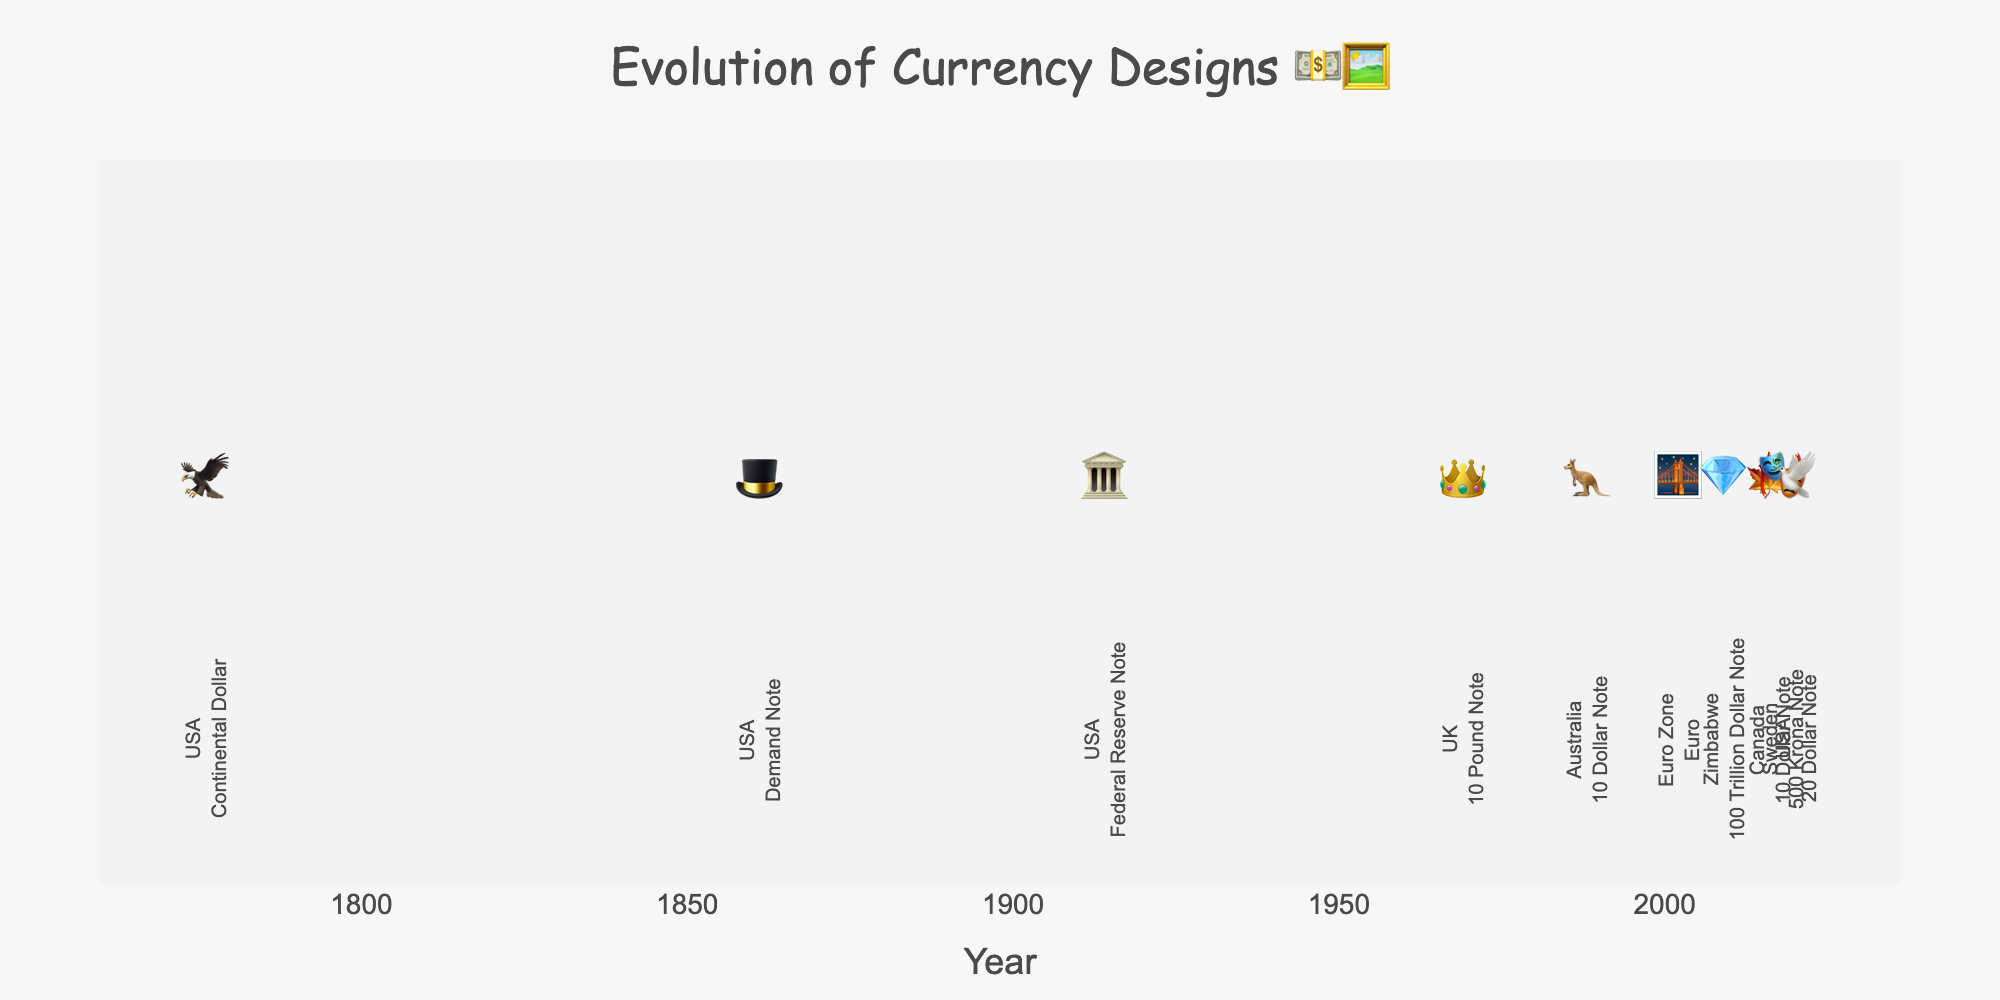Which country introduced a currency note with a kangaroo design in 1988? The emoji representation 🦘 along with the year 1988 indicates that it was Australia.
Answer: Australia Which country is represented with an eagle emoji on its currency and in which year? The eagle emoji 🦅 corresponds to the Continental Dollar introduced by the USA in 1776.
Answer: USA, 1776 What is the latest year shown in the figure, and which country does it represent? The latest year shown is 2020, and the emoji 🕊️ indicates the USA.
Answer: 2020, USA How many different countries' currency designs are included in the figure? There are unique country representations for the USA, the UK, Australia, the Euro Zone, Zimbabwe, Canada, and Sweden, totaling 7 different countries.
Answer: 7 Which two currencies are represented by emojis of a bridge and a crown? The bridge emoji 🌉 represents the Euro introduced in 2002, and the crown emoji 👑 represents the 10 Pound Note introduced in the UK in 1969.
Answer: Euro (2002), UK (1969) What is the chronological order of currency introductions from earliest to latest as shown in the figure? Based on the data points, the order is: 1776 (USA - 🦅), 1861 (USA - 🎩), 1914 (USA - 🏛️), 1969 (UK - 👑), 1988 (Australia - 🦘), 2002 (Euro - 🌉), 2009 (Zimbabwe - 💎), 2016 (Canada - 🍁), 2018 (Sweden - 🎭), 2020 (USA - 🕊️).
Answer: 1776, 1861, 1914, 1969, 1988, 2002, 2009, 2016, 2018, 2020 Which country introduced a currency note symbolized by a diamond and in what year? The diamond emoji 💎 represents the 100 Trillion Dollar Note introduced by Zimbabwe in 2009.
Answer: Zimbabwe, 2009 What is the average year of introduction for the given currency designs? Adding the years (1776, 1861, 1914, 1969, 1988, 2002, 2009, 2016, 2018, 2020) equals 17843. Dividing this by 10 gives an average year of 1784.3.
Answer: 1784.3 